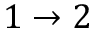Convert formula to latex. <formula><loc_0><loc_0><loc_500><loc_500>1 \to 2</formula> 